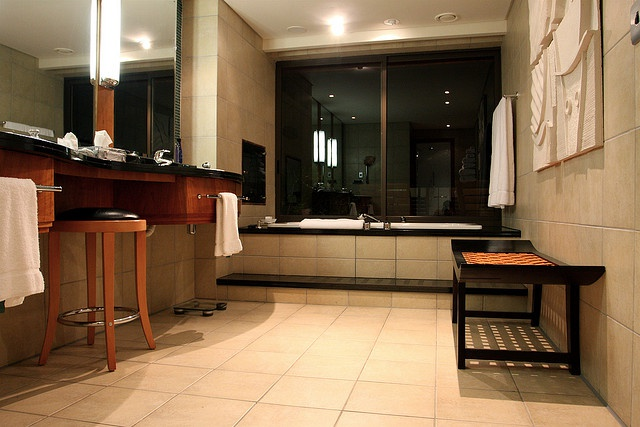Describe the objects in this image and their specific colors. I can see bench in darkgray, black, maroon, and orange tones, chair in darkgray, maroon, brown, and black tones, tv in darkgray, black, maroon, olive, and gray tones, and sink in darkgray, tan, black, and gray tones in this image. 